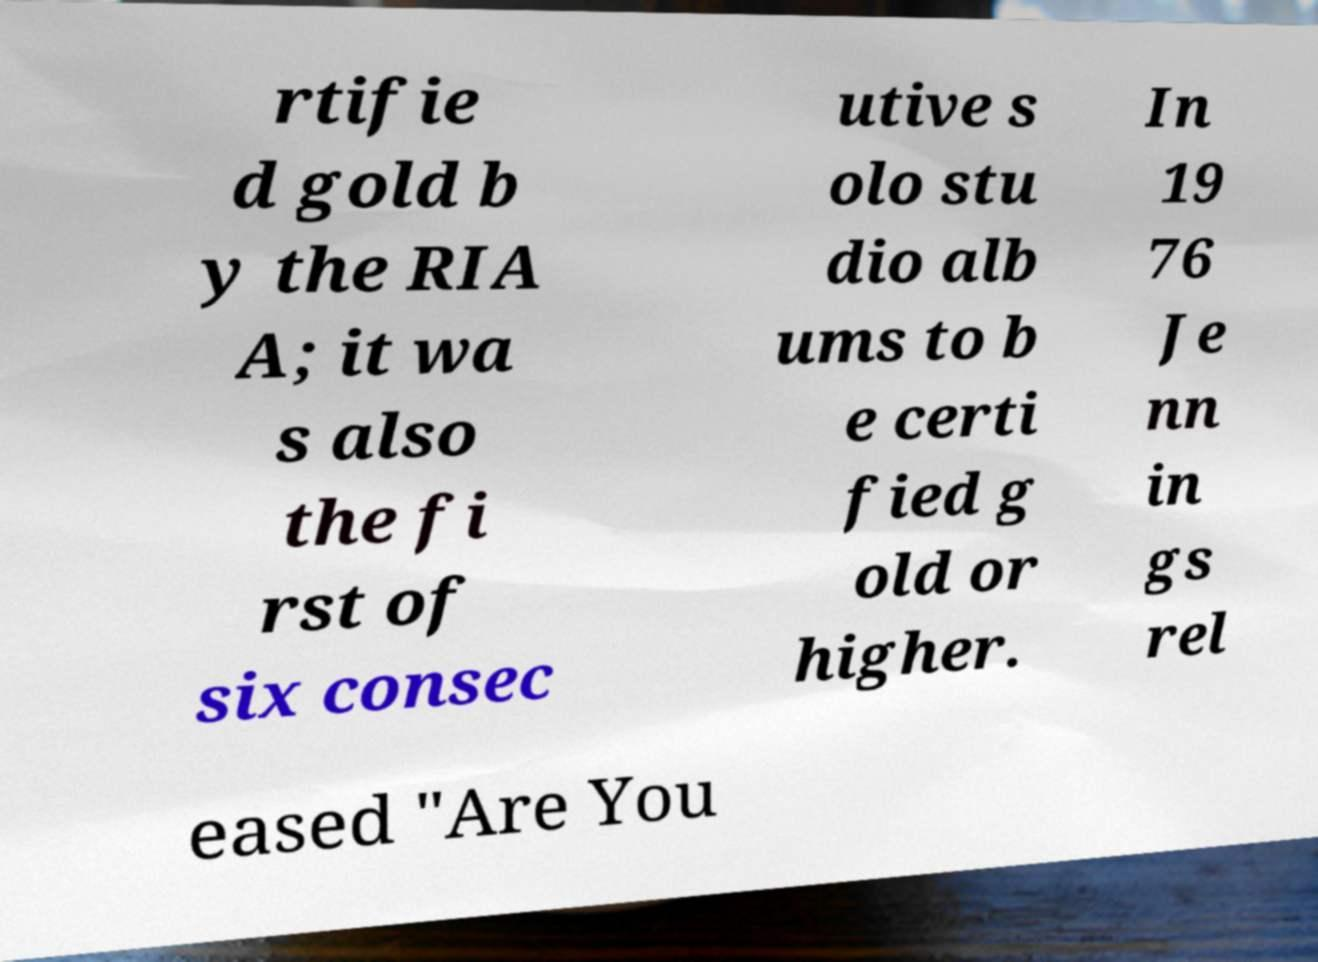I need the written content from this picture converted into text. Can you do that? rtifie d gold b y the RIA A; it wa s also the fi rst of six consec utive s olo stu dio alb ums to b e certi fied g old or higher. In 19 76 Je nn in gs rel eased "Are You 